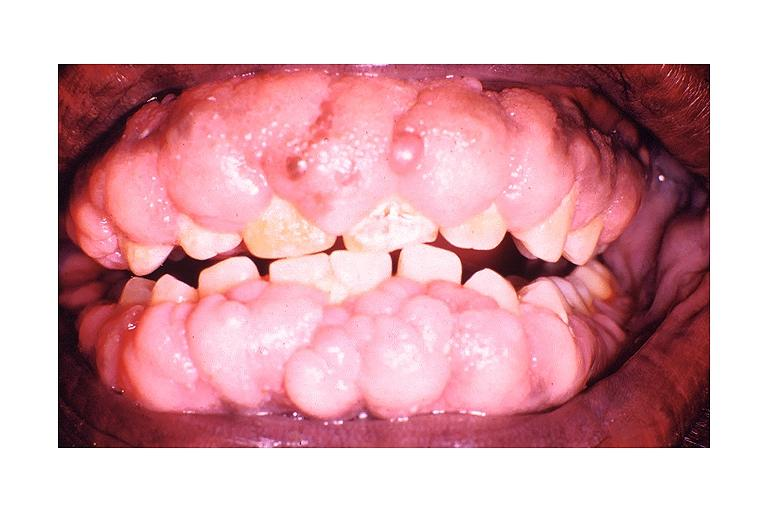s dilantin induced gingival hyperplasia?
Answer the question using a single word or phrase. Yes 